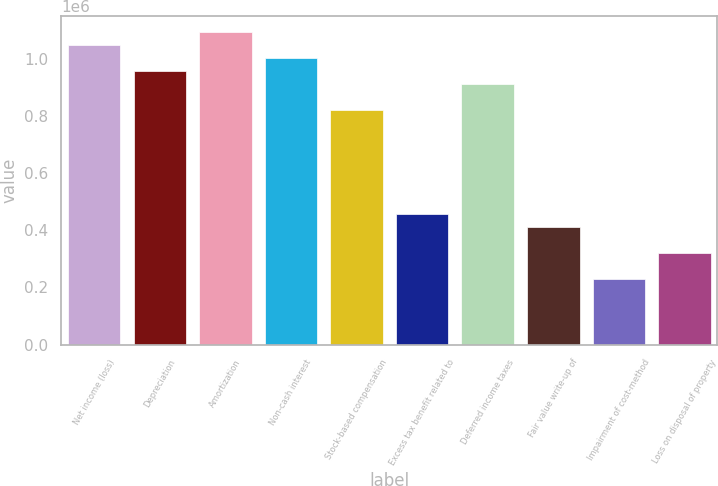<chart> <loc_0><loc_0><loc_500><loc_500><bar_chart><fcel>Net income (loss)<fcel>Depreciation<fcel>Amortization<fcel>Non-cash interest<fcel>Stock-based compensation<fcel>Excess tax benefit related to<fcel>Deferred income taxes<fcel>Fair value write-up of<fcel>Impairment of cost-method<fcel>Loss on disposal of property<nl><fcel>1.04873e+06<fcel>957542<fcel>1.09432e+06<fcel>1.00313e+06<fcel>820764<fcel>456024<fcel>911949<fcel>410432<fcel>228062<fcel>319246<nl></chart> 